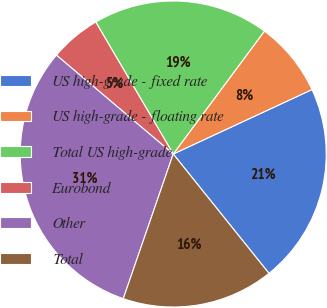Convert chart. <chart><loc_0><loc_0><loc_500><loc_500><pie_chart><fcel>US high-grade - fixed rate<fcel>US high-grade - floating rate<fcel>Total US high-grade<fcel>Eurobond<fcel>Other<fcel>Total<nl><fcel>21.16%<fcel>7.92%<fcel>18.61%<fcel>5.37%<fcel>30.89%<fcel>16.05%<nl></chart> 